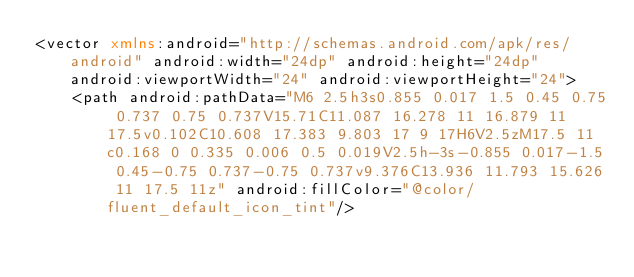<code> <loc_0><loc_0><loc_500><loc_500><_XML_><vector xmlns:android="http://schemas.android.com/apk/res/android" android:width="24dp" android:height="24dp" android:viewportWidth="24" android:viewportHeight="24">
    <path android:pathData="M6 2.5h3s0.855 0.017 1.5 0.45 0.75 0.737 0.75 0.737V15.71C11.087 16.278 11 16.879 11 17.5v0.102C10.608 17.383 9.803 17 9 17H6V2.5zM17.5 11c0.168 0 0.335 0.006 0.5 0.019V2.5h-3s-0.855 0.017-1.5 0.45-0.75 0.737-0.75 0.737v9.376C13.936 11.793 15.626 11 17.5 11z" android:fillColor="@color/fluent_default_icon_tint"/></code> 